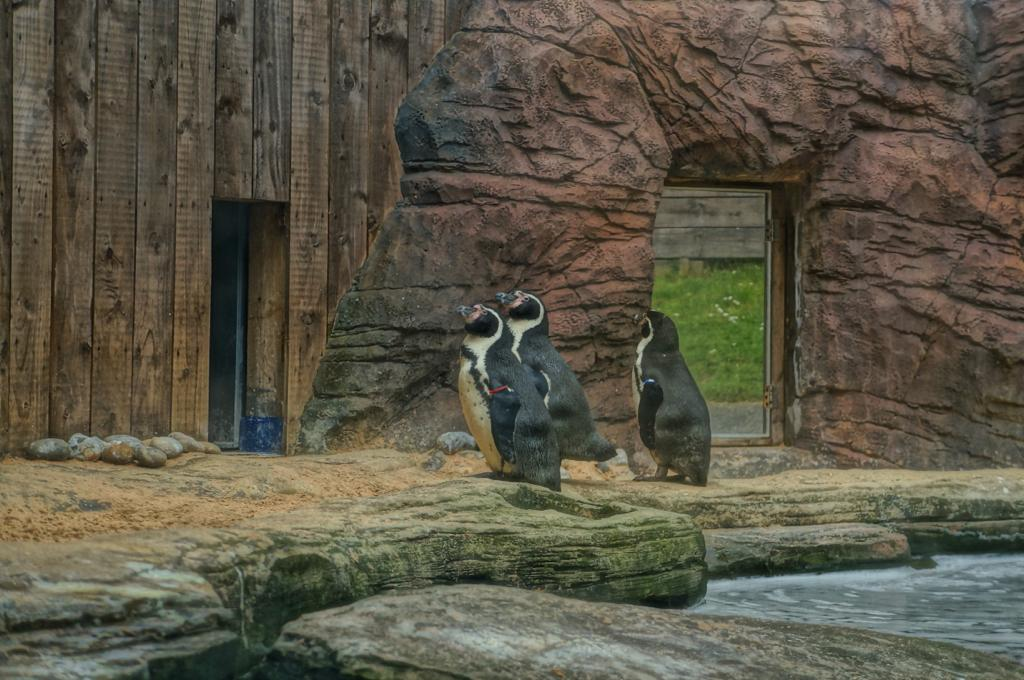What structure can be seen at the beginning of the image? There is an entrance arch in the image. What type of barrier is visible at the top of the image? A wooden fence is visible at the top of the image. What is located in the middle of the image? There is water in the middle of the image. What type of living creatures are present in the image? Animals are present in the image. What type of material can be seen in the image? Stones are visible in the image. What type of songs can be heard being sung by the animals in the image? There are no animals singing songs in the image; the animals are not anthropomorphized. Where is the playground located in the image? There is no playground present in the image. 